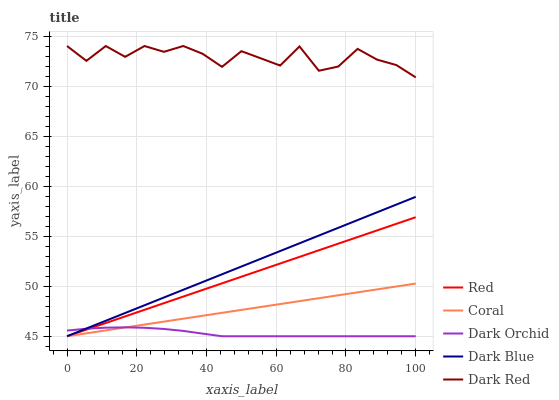Does Dark Orchid have the minimum area under the curve?
Answer yes or no. Yes. Does Dark Red have the maximum area under the curve?
Answer yes or no. Yes. Does Coral have the minimum area under the curve?
Answer yes or no. No. Does Coral have the maximum area under the curve?
Answer yes or no. No. Is Dark Blue the smoothest?
Answer yes or no. Yes. Is Dark Red the roughest?
Answer yes or no. Yes. Is Coral the smoothest?
Answer yes or no. No. Is Coral the roughest?
Answer yes or no. No. Does Dark Blue have the lowest value?
Answer yes or no. Yes. Does Dark Red have the lowest value?
Answer yes or no. No. Does Dark Red have the highest value?
Answer yes or no. Yes. Does Coral have the highest value?
Answer yes or no. No. Is Dark Orchid less than Dark Red?
Answer yes or no. Yes. Is Dark Red greater than Dark Blue?
Answer yes or no. Yes. Does Dark Blue intersect Coral?
Answer yes or no. Yes. Is Dark Blue less than Coral?
Answer yes or no. No. Is Dark Blue greater than Coral?
Answer yes or no. No. Does Dark Orchid intersect Dark Red?
Answer yes or no. No. 